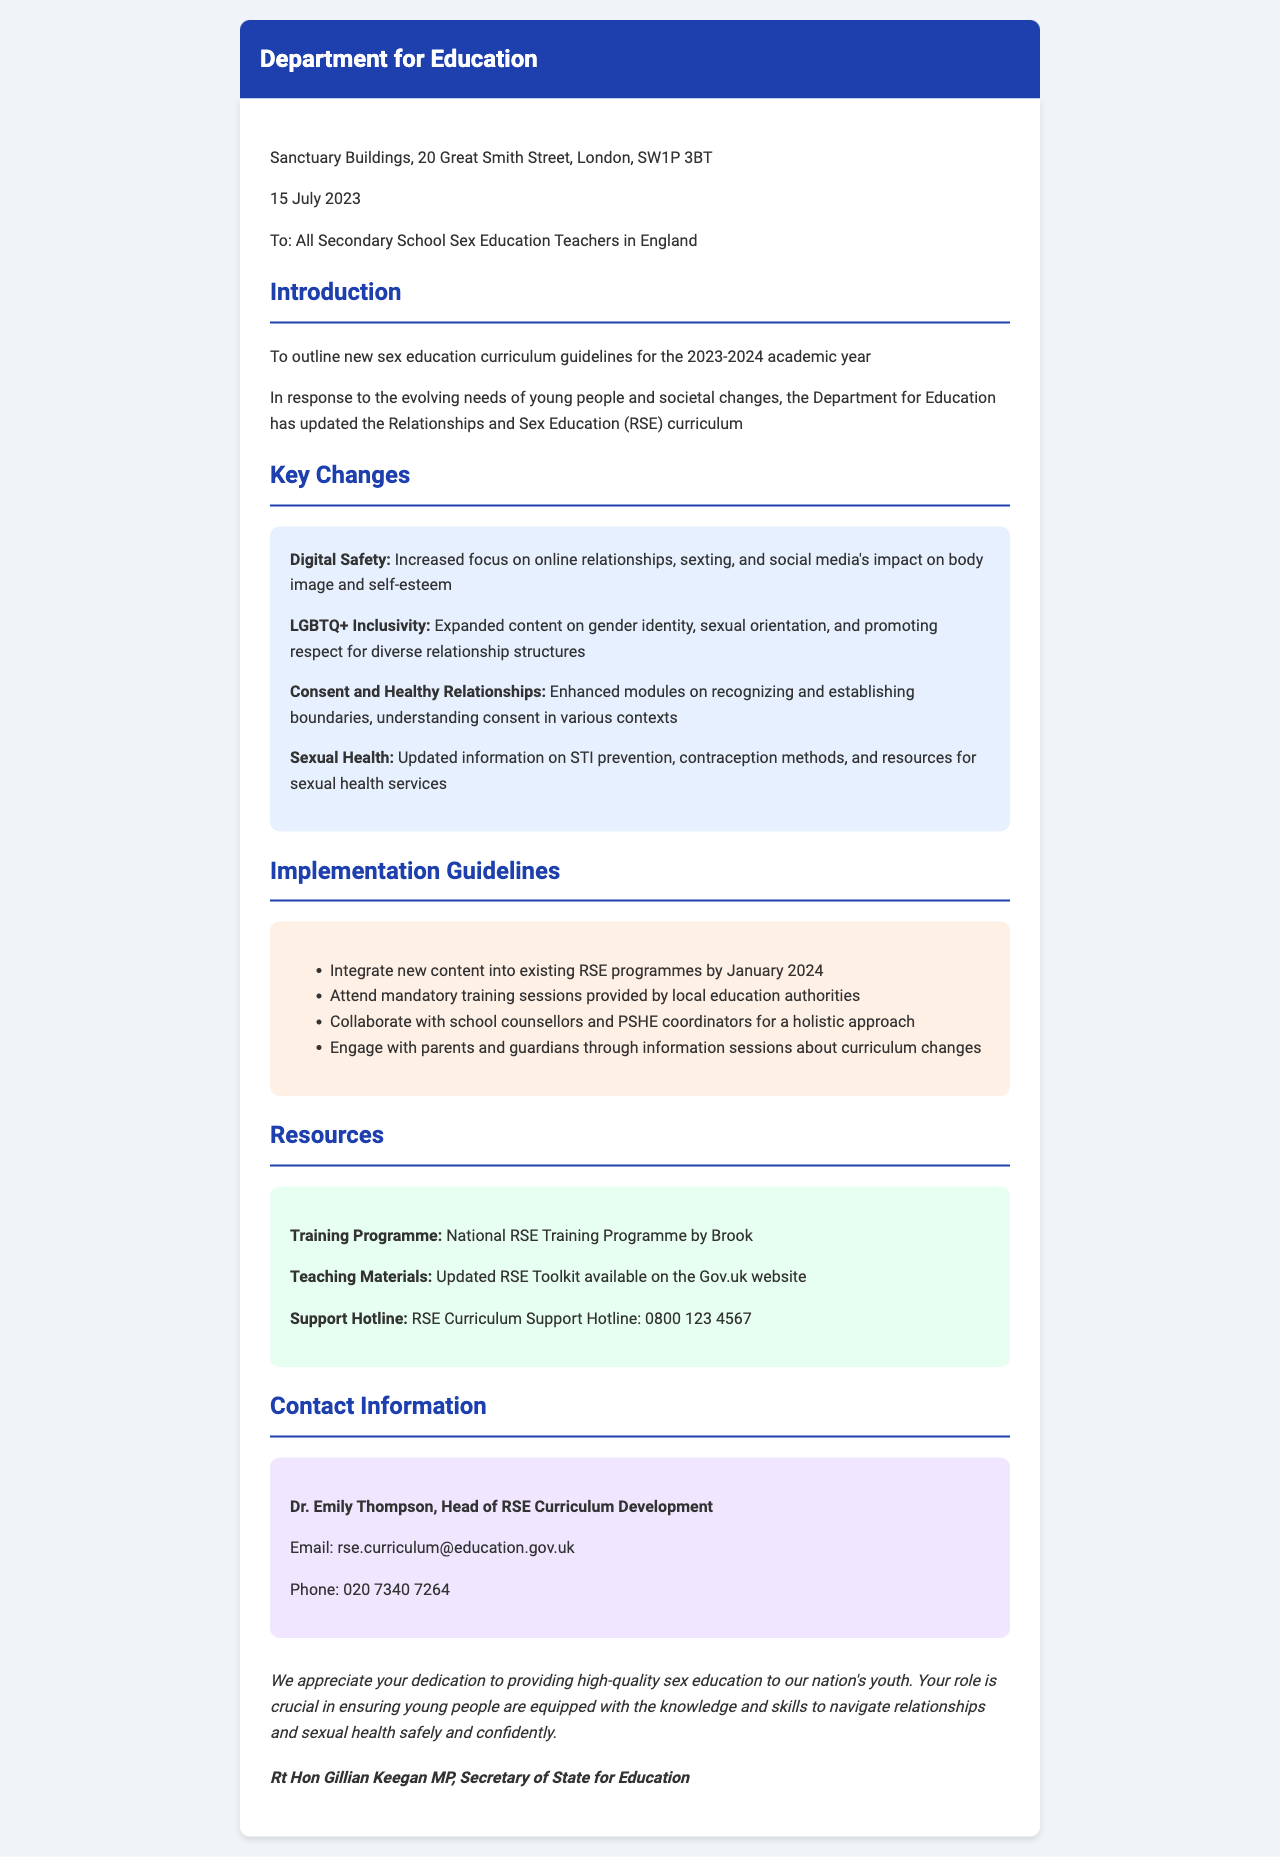What is the sender of the letter? The sender of the letter is stated at the top of the document.
Answer: Department for Education What is the date of the letter? The date is provided in the sender information section in the letter.
Answer: 15 July 2023 Who is the intended recipient of the letter? The recipient is mentioned in the address section of the letter.
Answer: All Secondary School Sex Education Teachers in England What new topic has increased focus on online relationships? This topic is listed in the key changes section of the document.
Answer: Digital Safety What is the mandatory deadline to integrate new content into existing programmes? The integration deadline is specified in the implementation guidelines of the letter.
Answer: January 2024 Who is the head of RSE Curriculum Development? This information is found in the contact information section of the letter.
Answer: Dr. Emily Thompson What is the support hotline number provided in the document? The support hotline number is included in the resources section of the letter.
Answer: 0800 123 4567 What is the main purpose of this letter? The purpose is stated in the introduction section of the letter.
Answer: To outline new sex education curriculum guidelines for the 2023-2024 academic year What is emphasized in the new guidelines concerning healthy relationships? This is mentioned in the key changes section discussing the importance of boundaries.
Answer: Enhanced modules on recognizing and establishing boundaries 